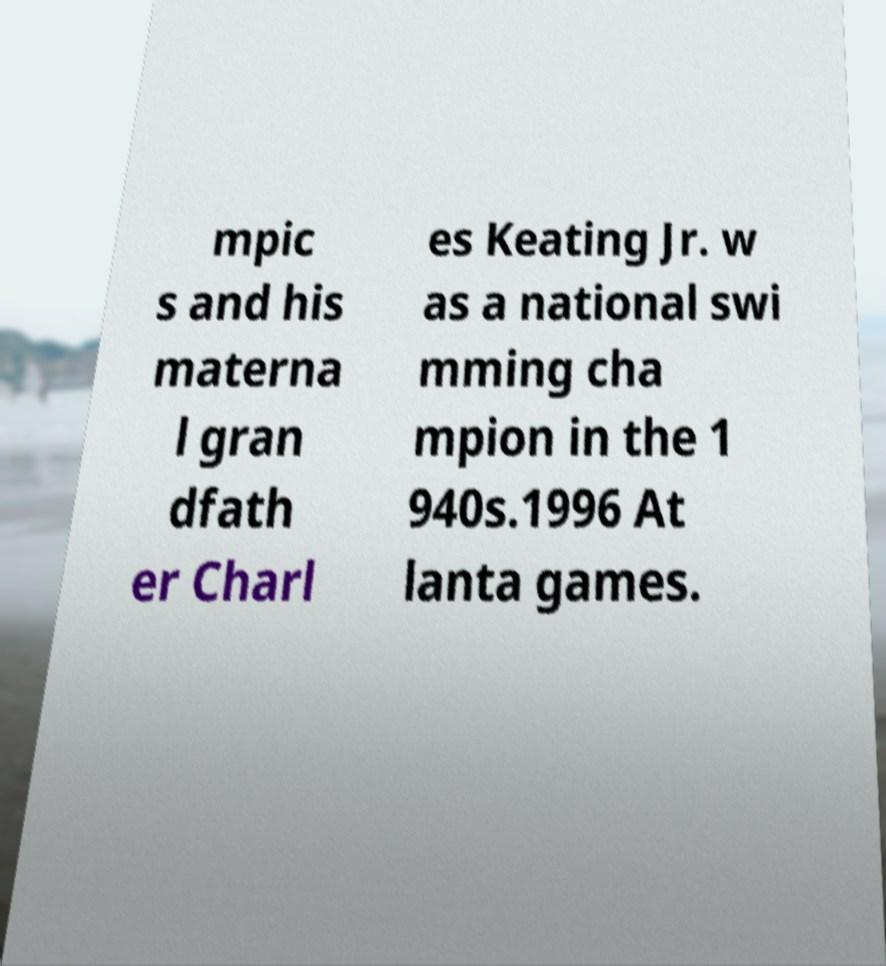Could you extract and type out the text from this image? mpic s and his materna l gran dfath er Charl es Keating Jr. w as a national swi mming cha mpion in the 1 940s.1996 At lanta games. 